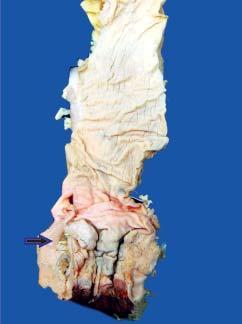does the anorectal margin show an ulcerated mucosa with thickened wall?
Answer the question using a single word or phrase. Yes 